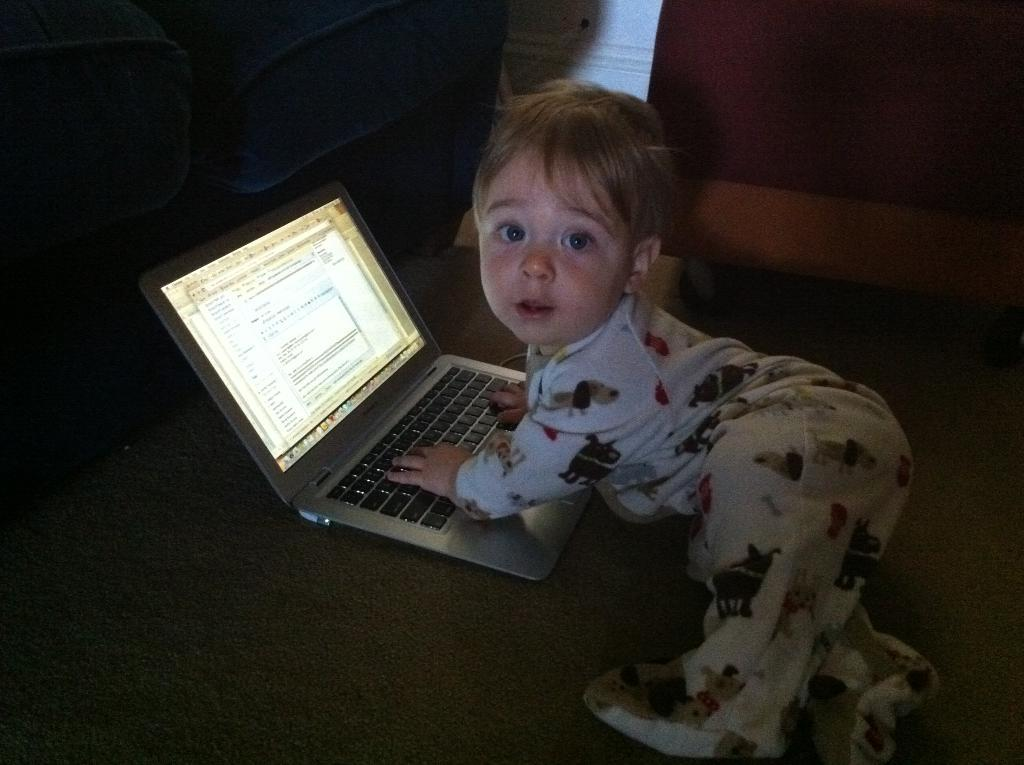What is the main subject of the image? There is a baby in the image. Where is the baby located? The baby is on a bed. What else can be seen on the bed in the image? There is a laptop on the bed in the image. How many sisters does the baby have in the image? There is no information about the baby's sisters in the image. 